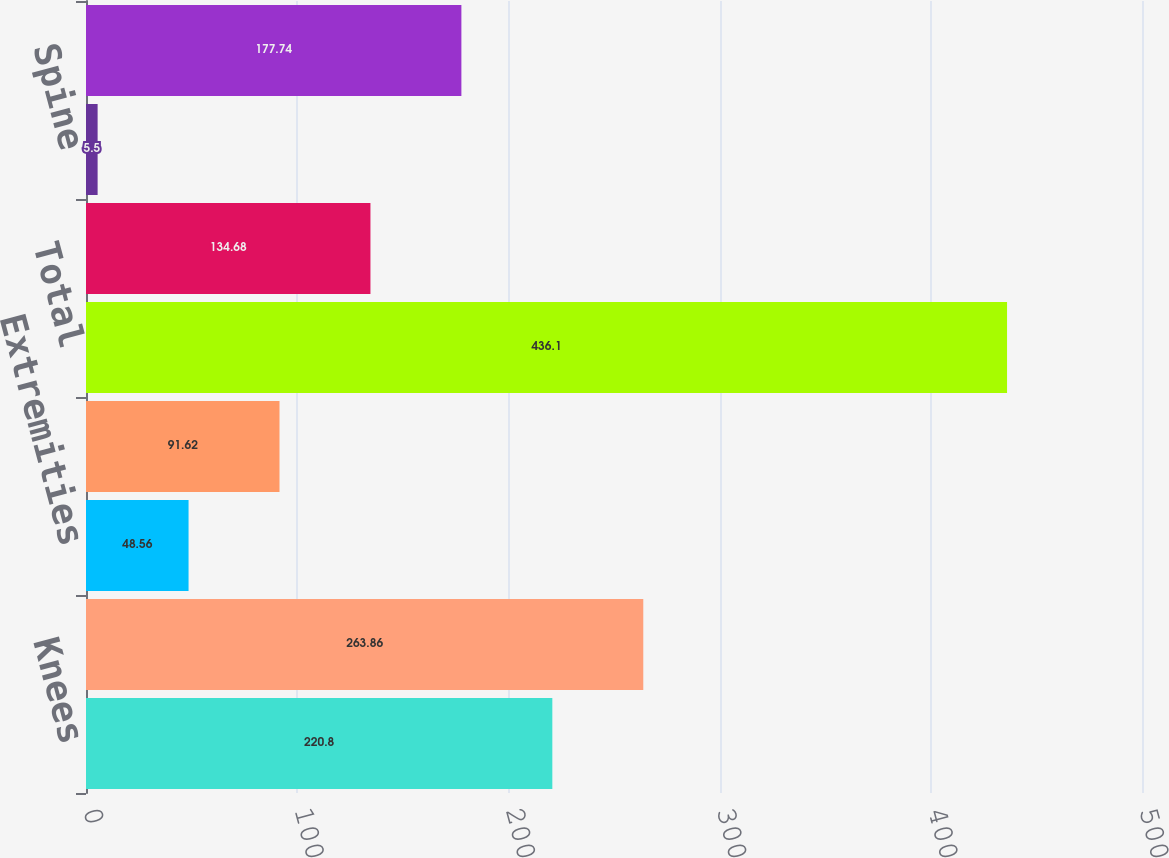<chart> <loc_0><loc_0><loc_500><loc_500><bar_chart><fcel>Knees<fcel>Hips<fcel>Extremities<fcel>Dental<fcel>Total<fcel>Trauma<fcel>Spine<fcel>OSP and Other<nl><fcel>220.8<fcel>263.86<fcel>48.56<fcel>91.62<fcel>436.1<fcel>134.68<fcel>5.5<fcel>177.74<nl></chart> 